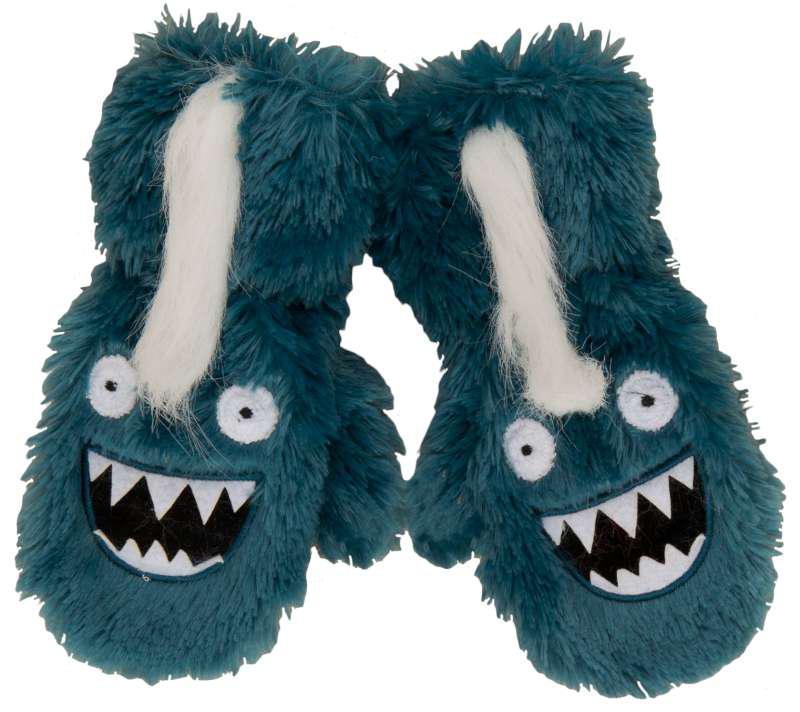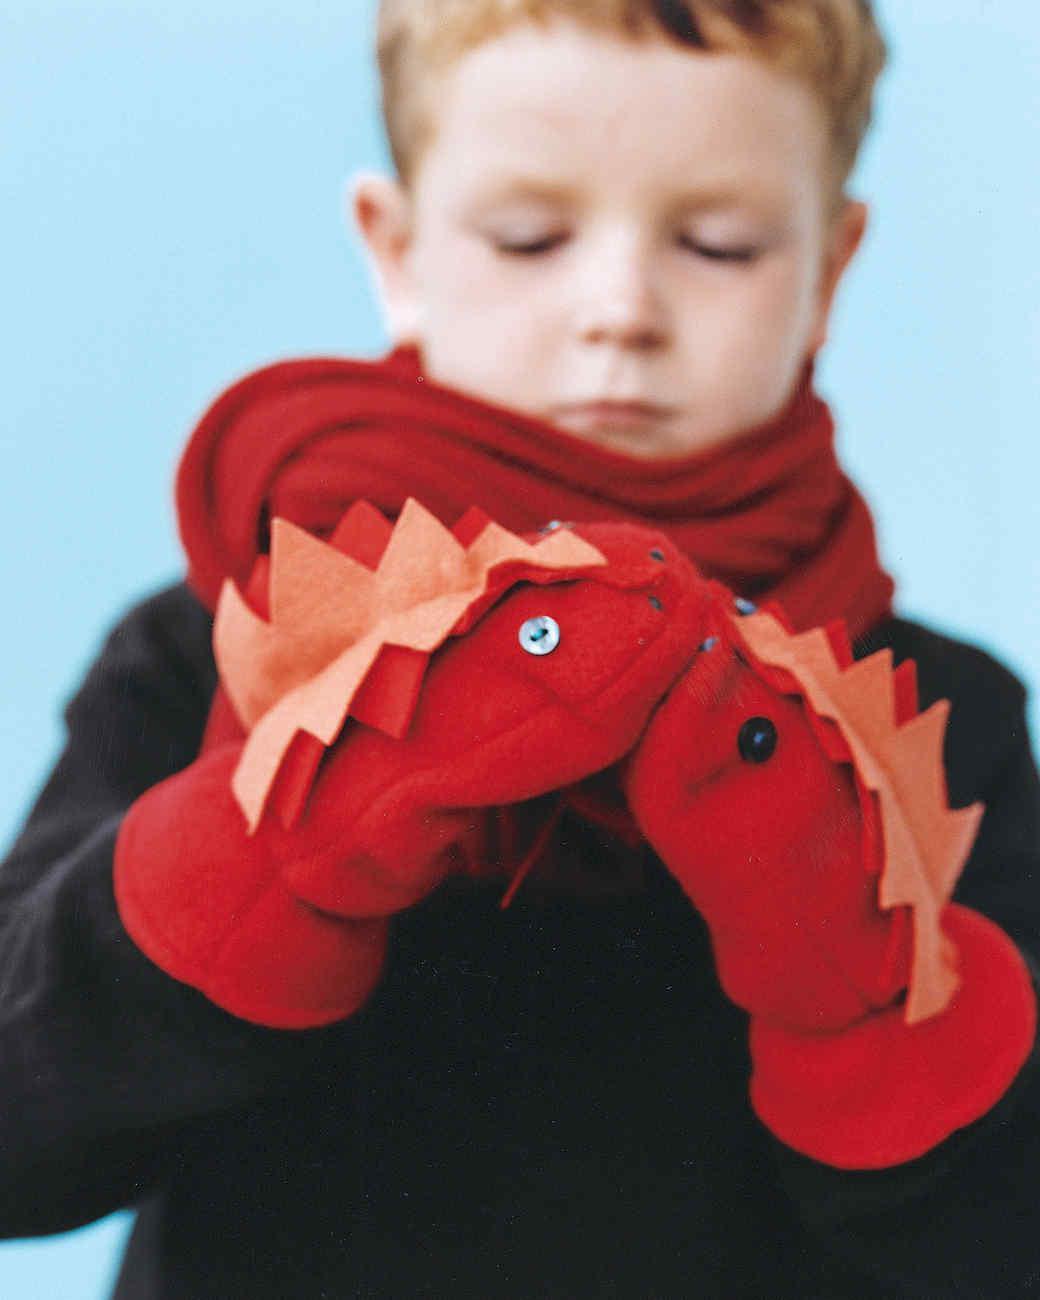The first image is the image on the left, the second image is the image on the right. Analyze the images presented: Is the assertion "there are at least two pairs of mittens in the image on the left" valid? Answer yes or no. No. The first image is the image on the left, the second image is the image on the right. For the images shown, is this caption "An image shows one pair of blue mittens with cartoon-like eyes, and no other mittens." true? Answer yes or no. Yes. The first image is the image on the left, the second image is the image on the right. Considering the images on both sides, is "One image shows a single pair of blue gloves that are not furry." valid? Answer yes or no. No. 